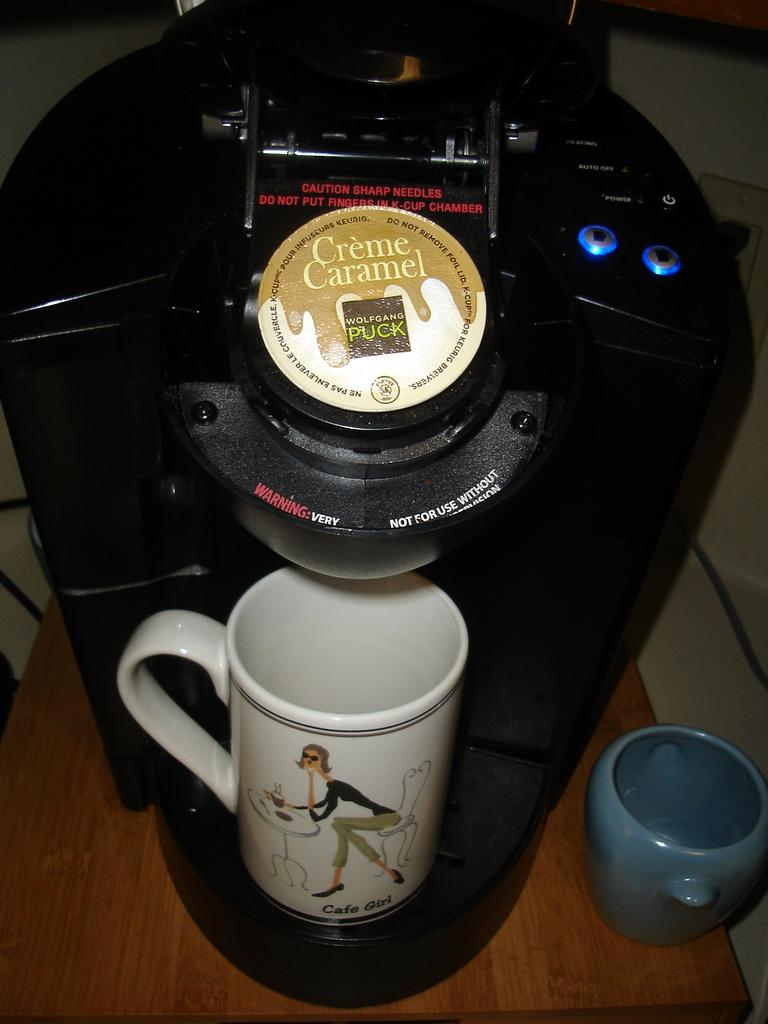<image>
Relay a brief, clear account of the picture shown. A coffee maker that has a flavoring of Creme Caramel waiting to boil 